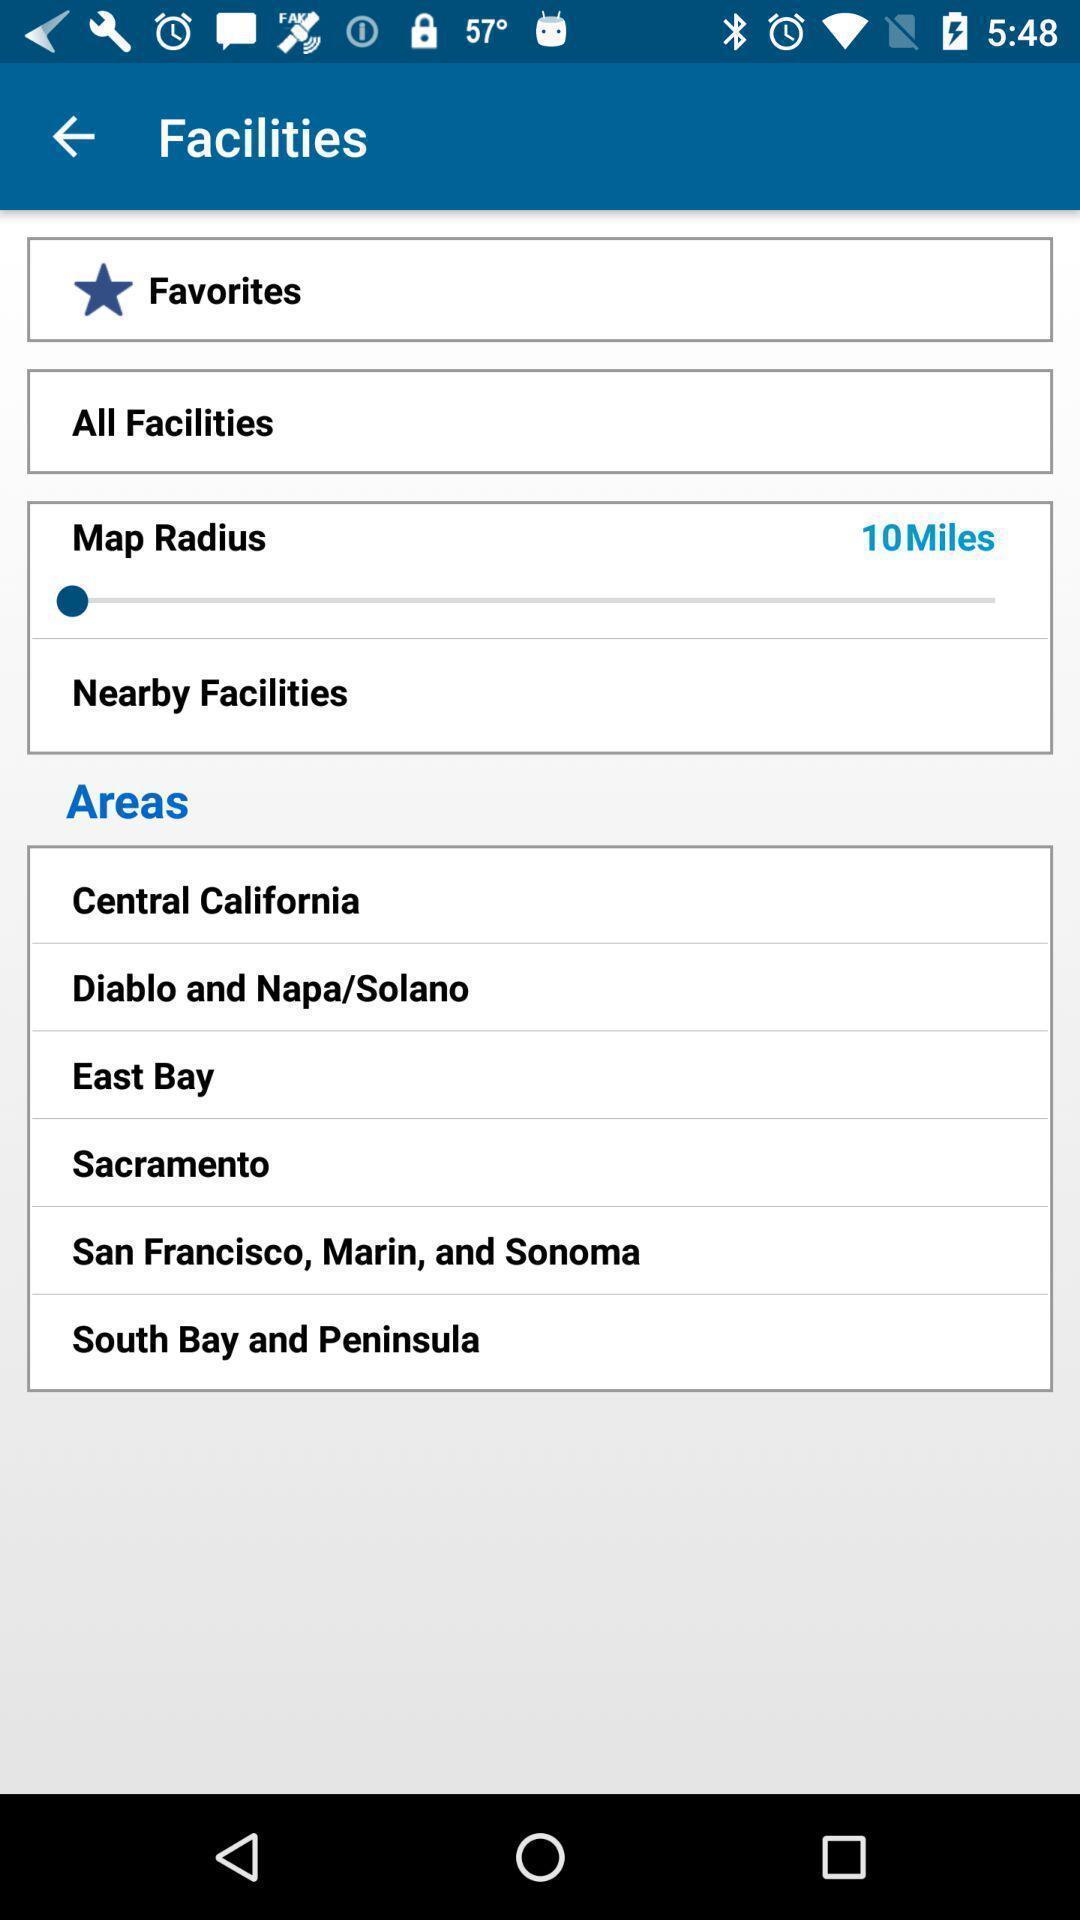What details can you identify in this image? Page showing the multiple options in facilities. 